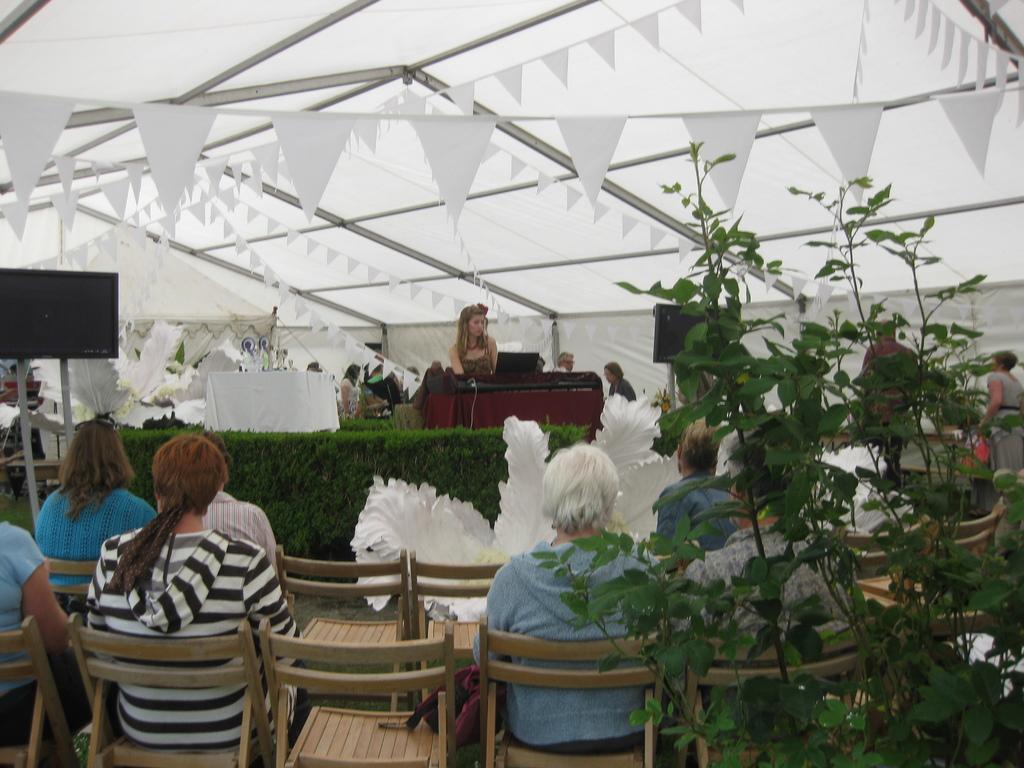Please provide a concise description of this image. This picture shows a group of people seated on the chairs and we see a television and few plants and we see a woman seated on the dais 